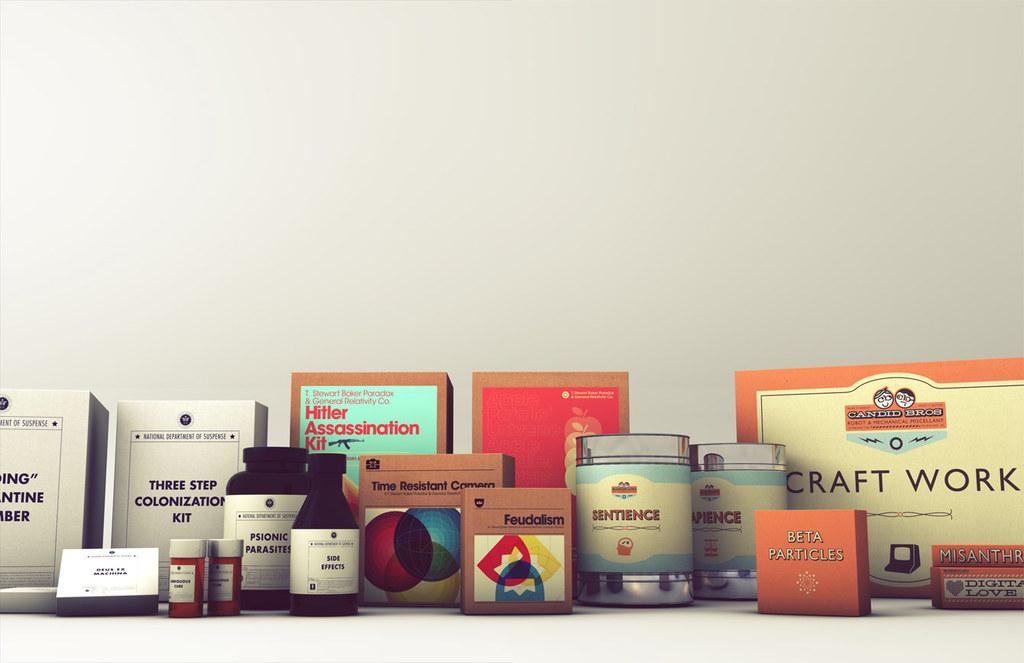What objects are present in the image? There are boxes and bottles in the image. Where are the boxes and bottles located? The boxes and bottles are on a platform. What is the color of the background in the image? The background of the image is white. How does the farmer increase the production of stew in the image? There is no farmer or stew present in the image; it features boxes and bottles on a platform with a white background. 